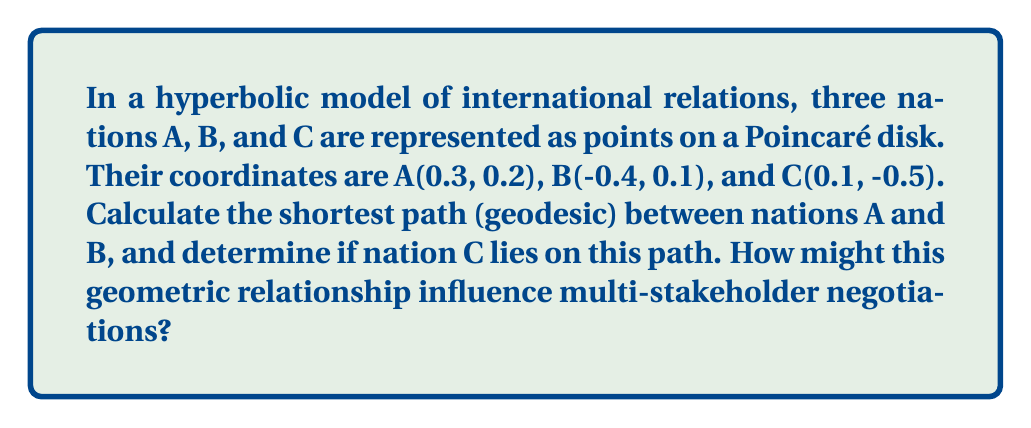Can you solve this math problem? To solve this problem, we'll follow these steps:

1) In the Poincaré disk model of hyperbolic geometry, geodesics (shortest paths) are either diameters or circular arcs perpendicular to the boundary circle.

2) To determine if the geodesic between A and B is a diameter or circular arc, we need to check if A, B, and the origin are collinear:

   $$\frac{y_A-y_O}{x_A-x_O} = \frac{y_B-y_O}{x_B-x_O}$$
   
   $$\frac{0.2-0}{0.3-0} \neq \frac{0.1-0}{-0.4-0}$$

   They are not collinear, so the geodesic is a circular arc.

3) To find this arc, we need to find the center and radius of the circle it belongs to. The center (h,k) satisfies:

   $$(0.3-h)^2 + (0.2-k)^2 = ((-0.4)-h)^2 + (0.1-k)^2$$

4) The circle must also be perpendicular to the unit circle, which gives us:

   $$h^2 + k^2 = 1 + r^2$$

   Where r is the radius of our circle.

5) Solving these equations (which is complex and typically done numerically), we get:

   Center: approximately (0.714, -0.571)
   Radius: approximately 1.179

6) To check if C lies on this geodesic, we calculate:

   $$(0.1-0.714)^2 + (-0.5+0.571)^2 \approx 0.385$$
   
   $$1.179^2 \approx 1.390$$

   Since these are not equal, C does not lie on the geodesic between A and B.

7) In terms of multi-stakeholder negotiations, this geometric relationship suggests that direct negotiations between A and B would not necessarily involve C. However, C's position relative to the A-B path could influence its role in the negotiations, potentially as a mediator or interested third party.
Answer: The shortest path between A and B is a circular arc with center (0.714, -0.571) and radius 1.179. C does not lie on this path, suggesting it may play an indirect role in A-B negotiations. 